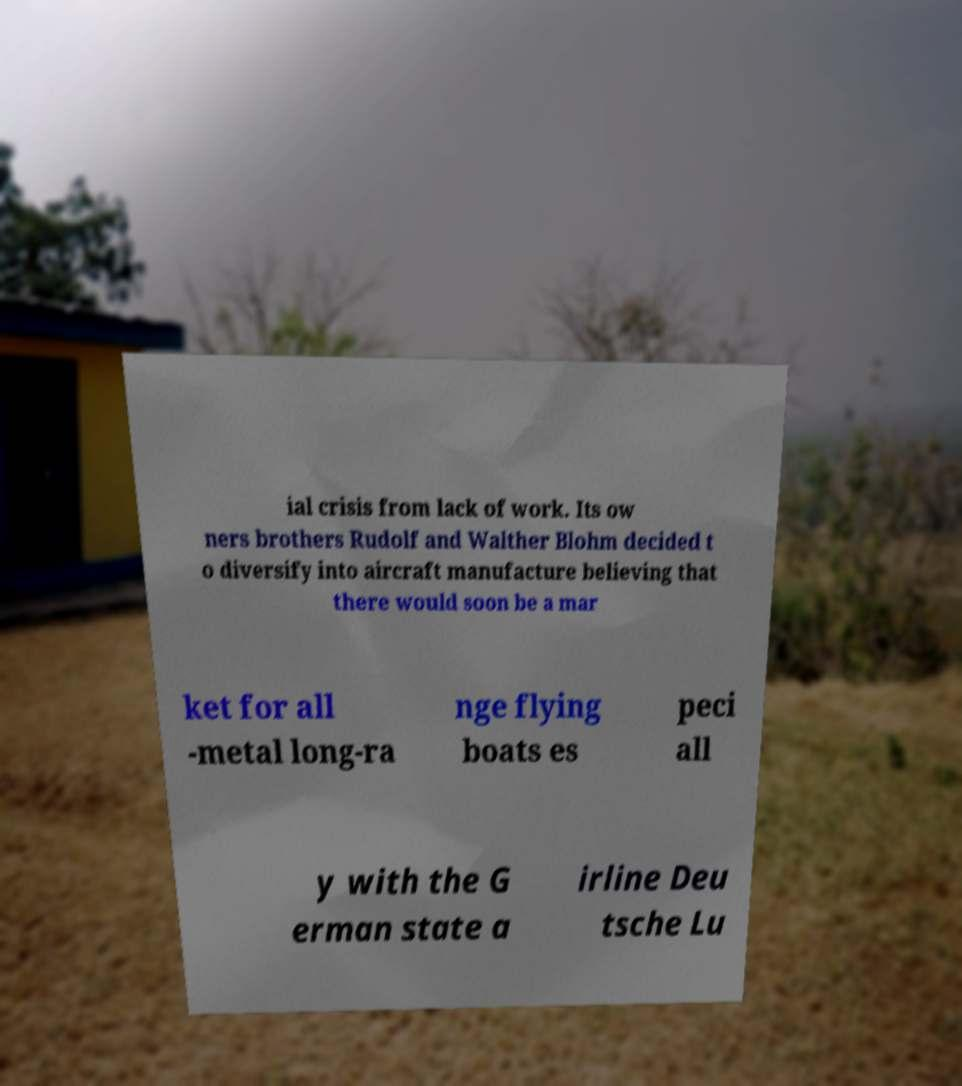Could you assist in decoding the text presented in this image and type it out clearly? ial crisis from lack of work. Its ow ners brothers Rudolf and Walther Blohm decided t o diversify into aircraft manufacture believing that there would soon be a mar ket for all -metal long-ra nge flying boats es peci all y with the G erman state a irline Deu tsche Lu 